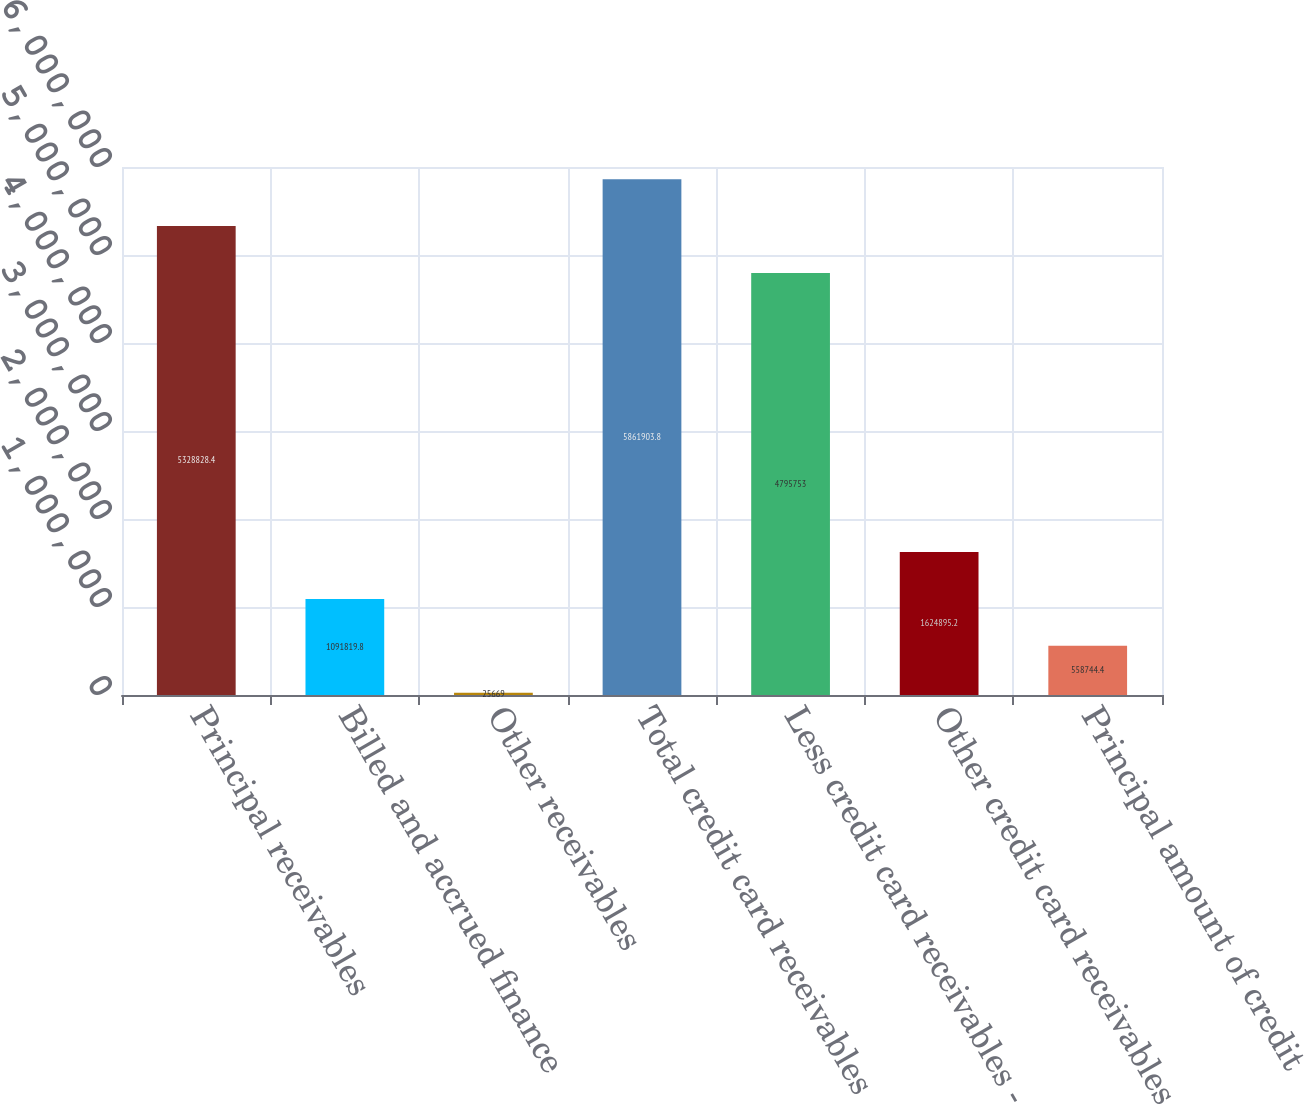Convert chart to OTSL. <chart><loc_0><loc_0><loc_500><loc_500><bar_chart><fcel>Principal receivables<fcel>Billed and accrued finance<fcel>Other receivables<fcel>Total credit card receivables<fcel>Less credit card receivables -<fcel>Other credit card receivables<fcel>Principal amount of credit<nl><fcel>5.32883e+06<fcel>1.09182e+06<fcel>25669<fcel>5.8619e+06<fcel>4.79575e+06<fcel>1.6249e+06<fcel>558744<nl></chart> 